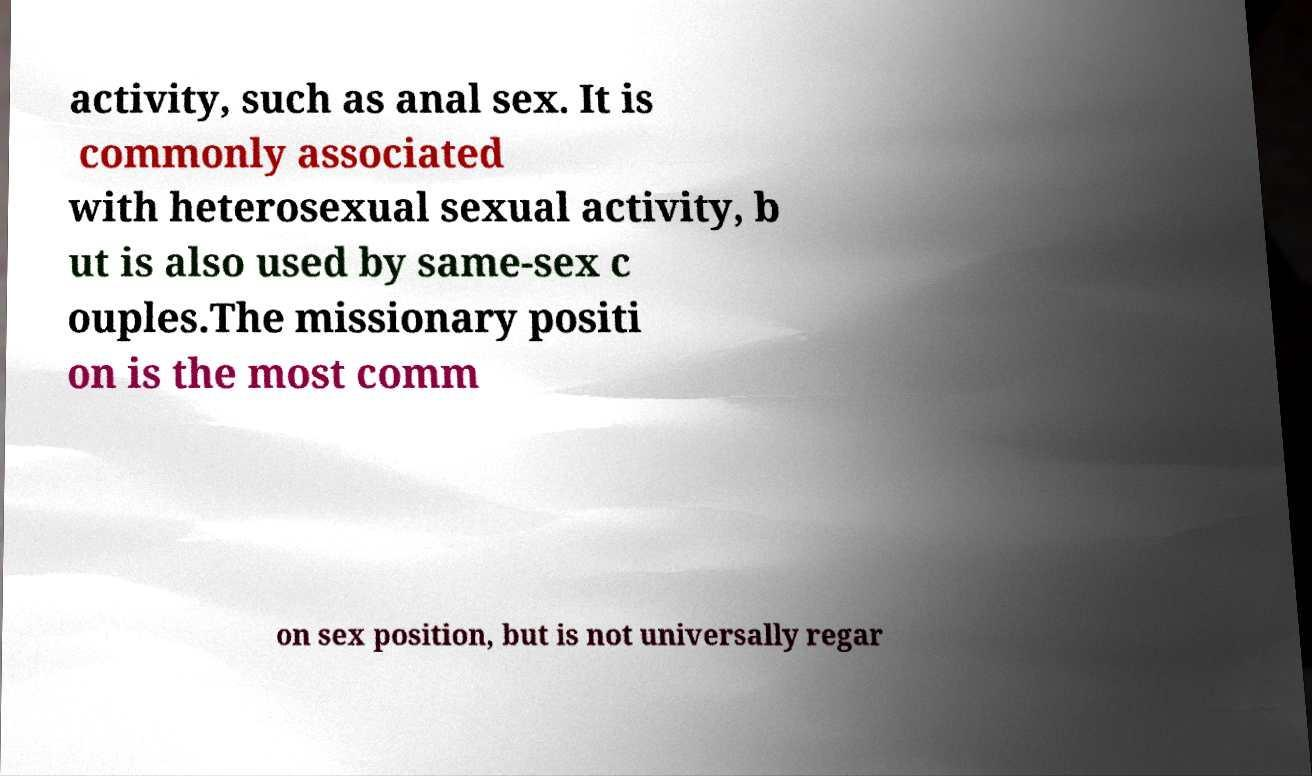For documentation purposes, I need the text within this image transcribed. Could you provide that? activity, such as anal sex. It is commonly associated with heterosexual sexual activity, b ut is also used by same-sex c ouples.The missionary positi on is the most comm on sex position, but is not universally regar 